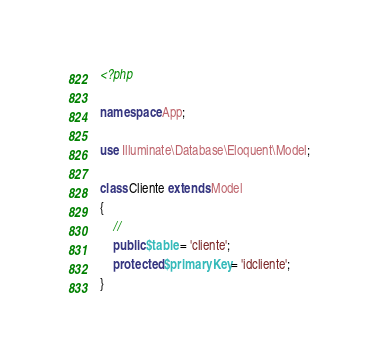<code> <loc_0><loc_0><loc_500><loc_500><_PHP_><?php

namespace App;

use Illuminate\Database\Eloquent\Model;

class Cliente extends Model
{
    //
    public $table = 'cliente';
    protected $primaryKey = 'idcliente';
}
</code> 